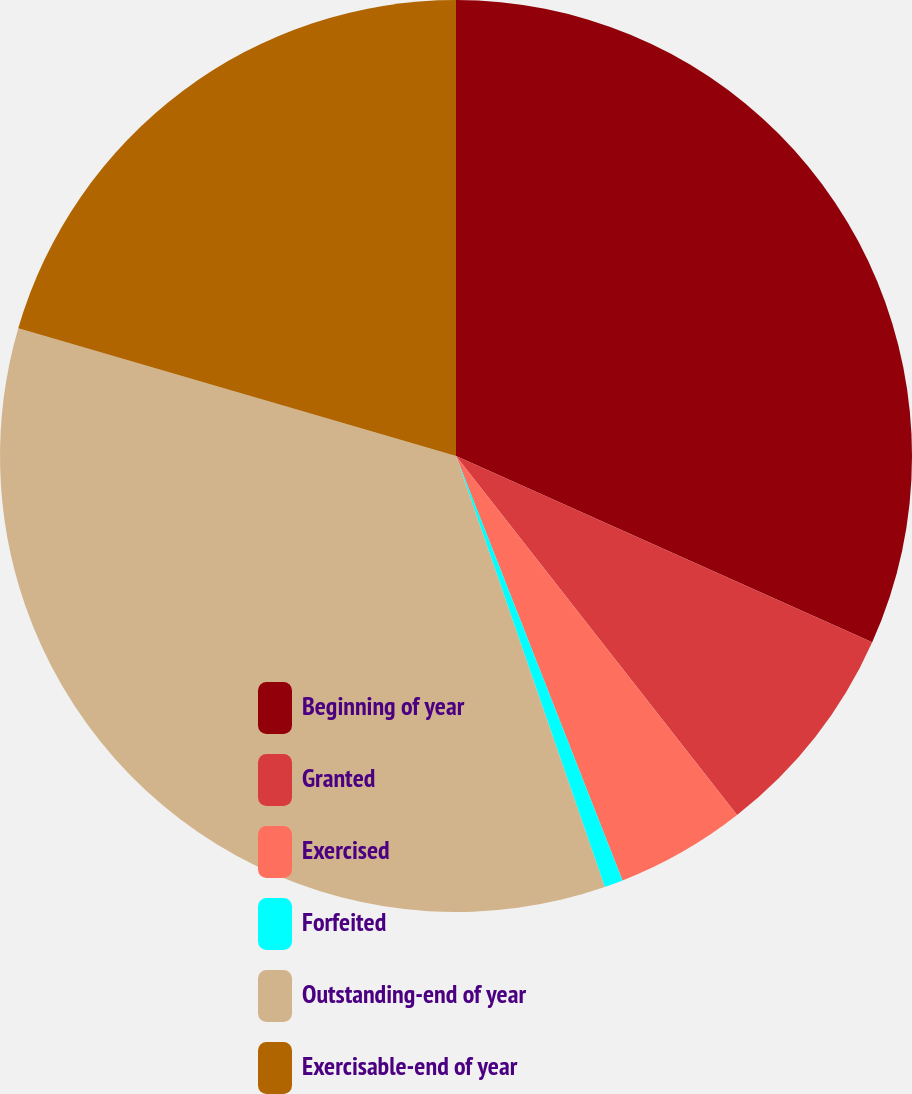Convert chart to OTSL. <chart><loc_0><loc_0><loc_500><loc_500><pie_chart><fcel>Beginning of year<fcel>Granted<fcel>Exercised<fcel>Forfeited<fcel>Outstanding-end of year<fcel>Exercisable-end of year<nl><fcel>31.7%<fcel>7.73%<fcel>4.62%<fcel>0.66%<fcel>34.81%<fcel>20.48%<nl></chart> 